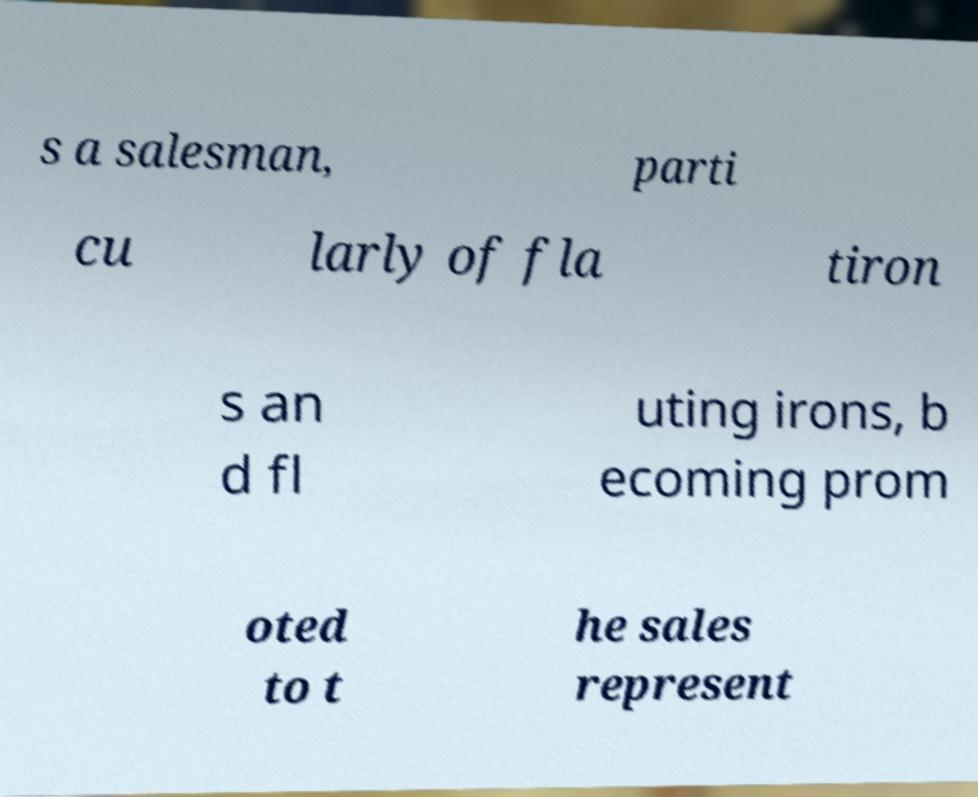For documentation purposes, I need the text within this image transcribed. Could you provide that? s a salesman, parti cu larly of fla tiron s an d fl uting irons, b ecoming prom oted to t he sales represent 